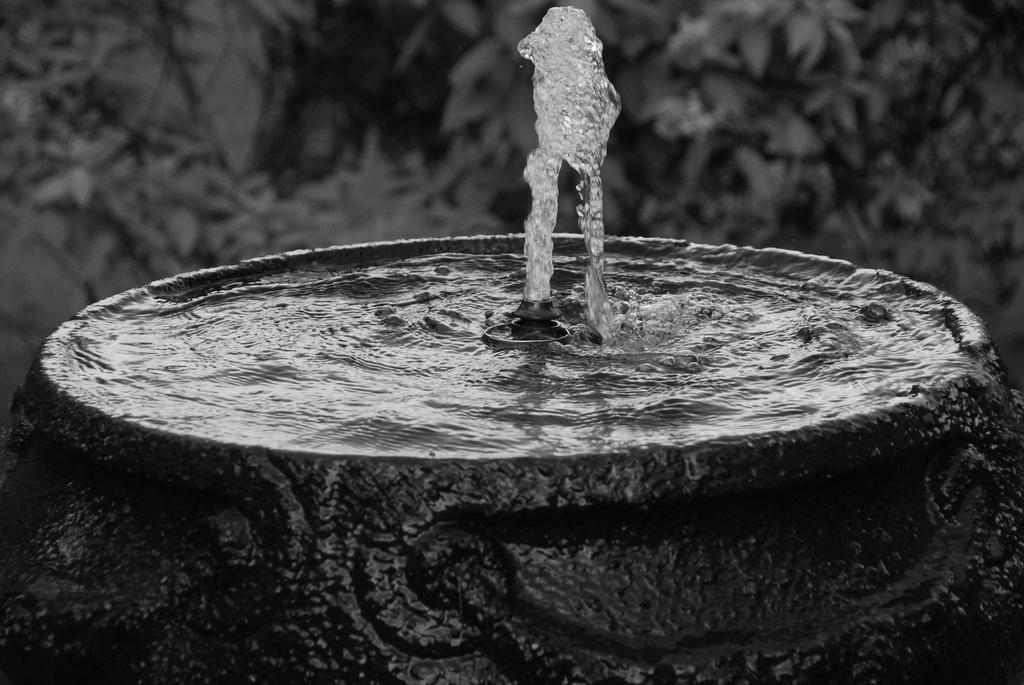What is the main feature in the image? There is a fountain in the image. What can be seen in the background of the image? There are plants in the background of the image. How many scarecrows are present in the image? There are no scarecrows present in the image. What type of pets can be seen playing near the fountain in the image? There are no pets visible in the image; it only features a fountain and plants in the background. 